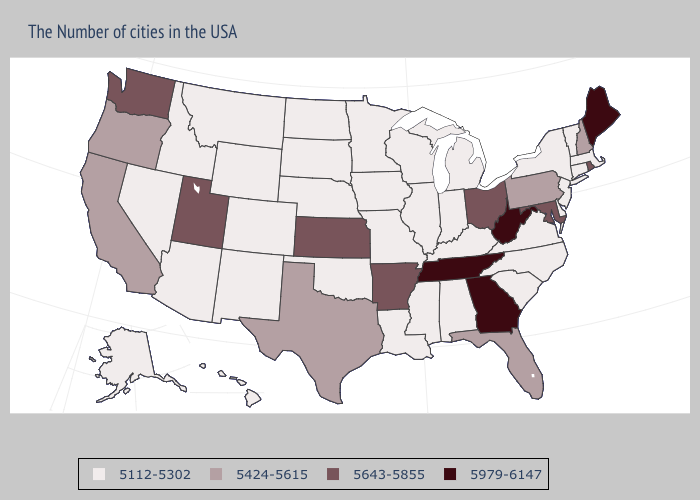Which states have the lowest value in the South?
Be succinct. Delaware, Virginia, North Carolina, South Carolina, Kentucky, Alabama, Mississippi, Louisiana, Oklahoma. Name the states that have a value in the range 5643-5855?
Concise answer only. Rhode Island, Maryland, Ohio, Arkansas, Kansas, Utah, Washington. Does the first symbol in the legend represent the smallest category?
Answer briefly. Yes. What is the highest value in the USA?
Keep it brief. 5979-6147. Name the states that have a value in the range 5643-5855?
Short answer required. Rhode Island, Maryland, Ohio, Arkansas, Kansas, Utah, Washington. What is the lowest value in the Northeast?
Give a very brief answer. 5112-5302. Does Maine have a higher value than New Mexico?
Concise answer only. Yes. Name the states that have a value in the range 5643-5855?
Keep it brief. Rhode Island, Maryland, Ohio, Arkansas, Kansas, Utah, Washington. Among the states that border Tennessee , does Mississippi have the lowest value?
Quick response, please. Yes. Name the states that have a value in the range 5643-5855?
Be succinct. Rhode Island, Maryland, Ohio, Arkansas, Kansas, Utah, Washington. Does Delaware have a lower value than Maine?
Give a very brief answer. Yes. Among the states that border South Carolina , which have the highest value?
Give a very brief answer. Georgia. Name the states that have a value in the range 5112-5302?
Keep it brief. Massachusetts, Vermont, Connecticut, New York, New Jersey, Delaware, Virginia, North Carolina, South Carolina, Michigan, Kentucky, Indiana, Alabama, Wisconsin, Illinois, Mississippi, Louisiana, Missouri, Minnesota, Iowa, Nebraska, Oklahoma, South Dakota, North Dakota, Wyoming, Colorado, New Mexico, Montana, Arizona, Idaho, Nevada, Alaska, Hawaii. Does Louisiana have a lower value than Texas?
Keep it brief. Yes. Does the map have missing data?
Answer briefly. No. 